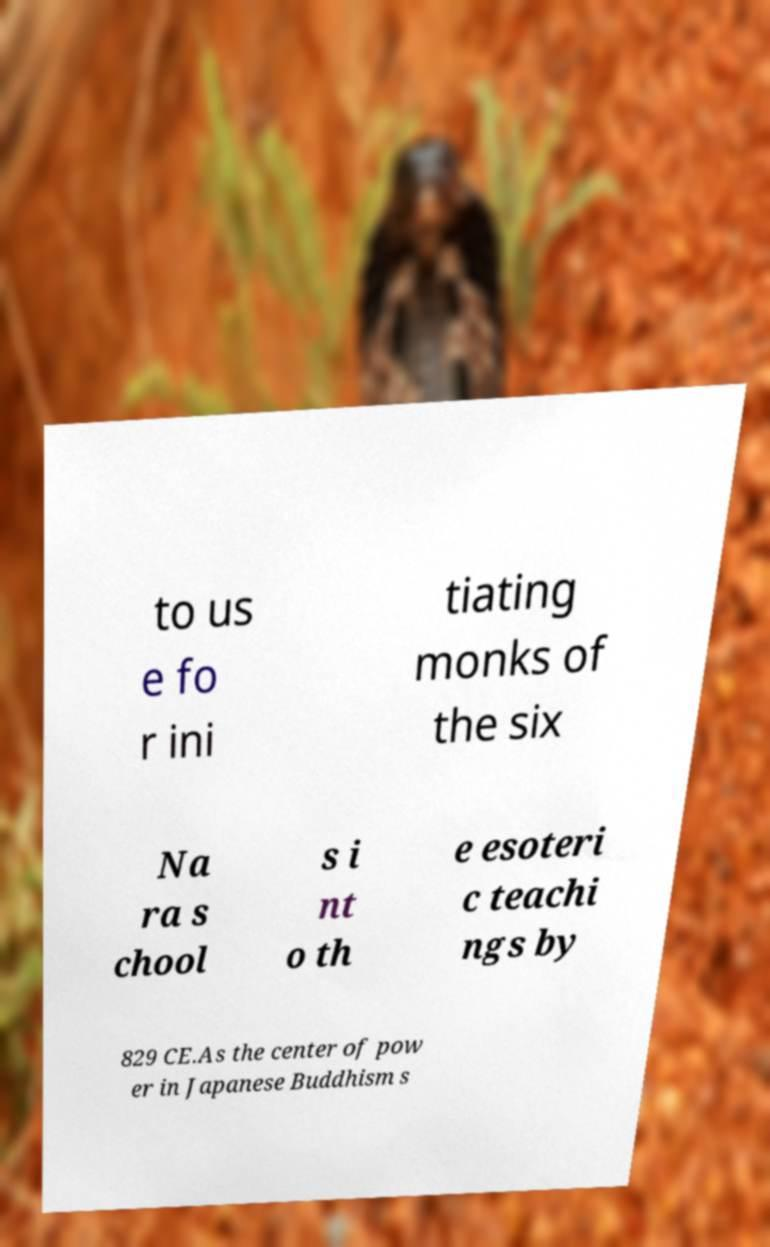Could you assist in decoding the text presented in this image and type it out clearly? to us e fo r ini tiating monks of the six Na ra s chool s i nt o th e esoteri c teachi ngs by 829 CE.As the center of pow er in Japanese Buddhism s 